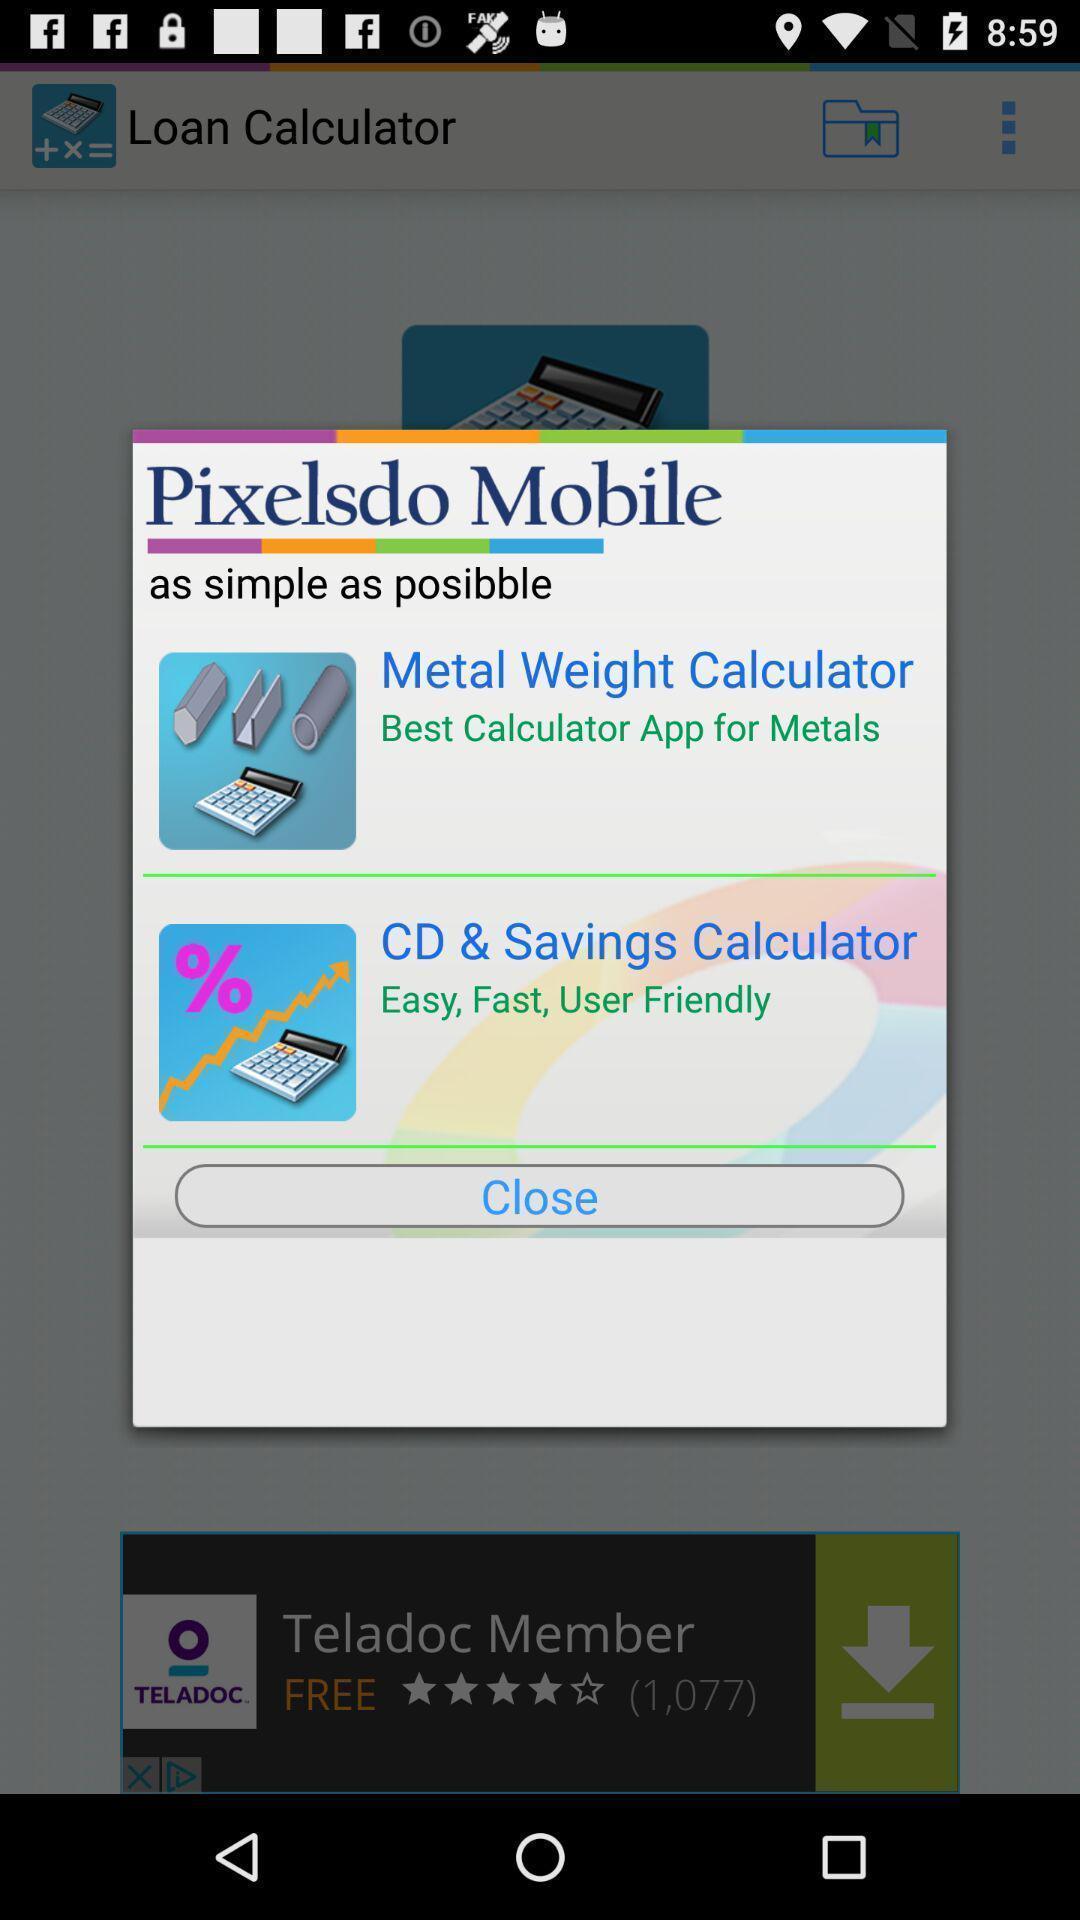Tell me about the visual elements in this screen capture. Popup showing two types of calculators in financial app. 